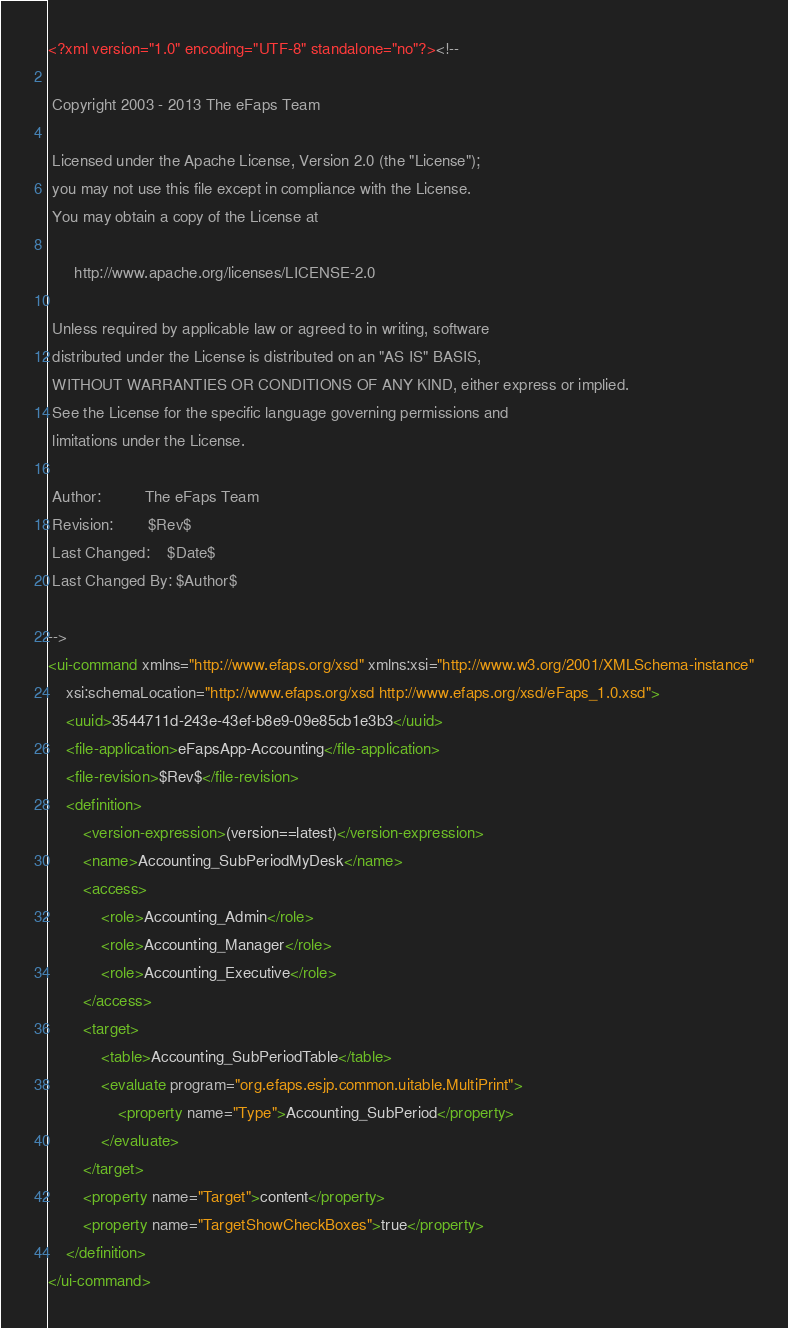<code> <loc_0><loc_0><loc_500><loc_500><_XML_><?xml version="1.0" encoding="UTF-8" standalone="no"?><!--

 Copyright 2003 - 2013 The eFaps Team

 Licensed under the Apache License, Version 2.0 (the "License");
 you may not use this file except in compliance with the License.
 You may obtain a copy of the License at

      http://www.apache.org/licenses/LICENSE-2.0

 Unless required by applicable law or agreed to in writing, software
 distributed under the License is distributed on an "AS IS" BASIS,
 WITHOUT WARRANTIES OR CONDITIONS OF ANY KIND, either express or implied.
 See the License for the specific language governing permissions and
 limitations under the License.

 Author:          The eFaps Team
 Revision:        $Rev$
 Last Changed:    $Date$
 Last Changed By: $Author$

-->
<ui-command xmlns="http://www.efaps.org/xsd" xmlns:xsi="http://www.w3.org/2001/XMLSchema-instance"
    xsi:schemaLocation="http://www.efaps.org/xsd http://www.efaps.org/xsd/eFaps_1.0.xsd">
    <uuid>3544711d-243e-43ef-b8e9-09e85cb1e3b3</uuid>
    <file-application>eFapsApp-Accounting</file-application>
    <file-revision>$Rev$</file-revision>
    <definition>
        <version-expression>(version==latest)</version-expression>
        <name>Accounting_SubPeriodMyDesk</name>
        <access>
            <role>Accounting_Admin</role>
            <role>Accounting_Manager</role>
            <role>Accounting_Executive</role>
        </access>
        <target>
            <table>Accounting_SubPeriodTable</table>
            <evaluate program="org.efaps.esjp.common.uitable.MultiPrint">
                <property name="Type">Accounting_SubPeriod</property>
            </evaluate>
        </target>
        <property name="Target">content</property>
        <property name="TargetShowCheckBoxes">true</property>
    </definition>
</ui-command>
</code> 